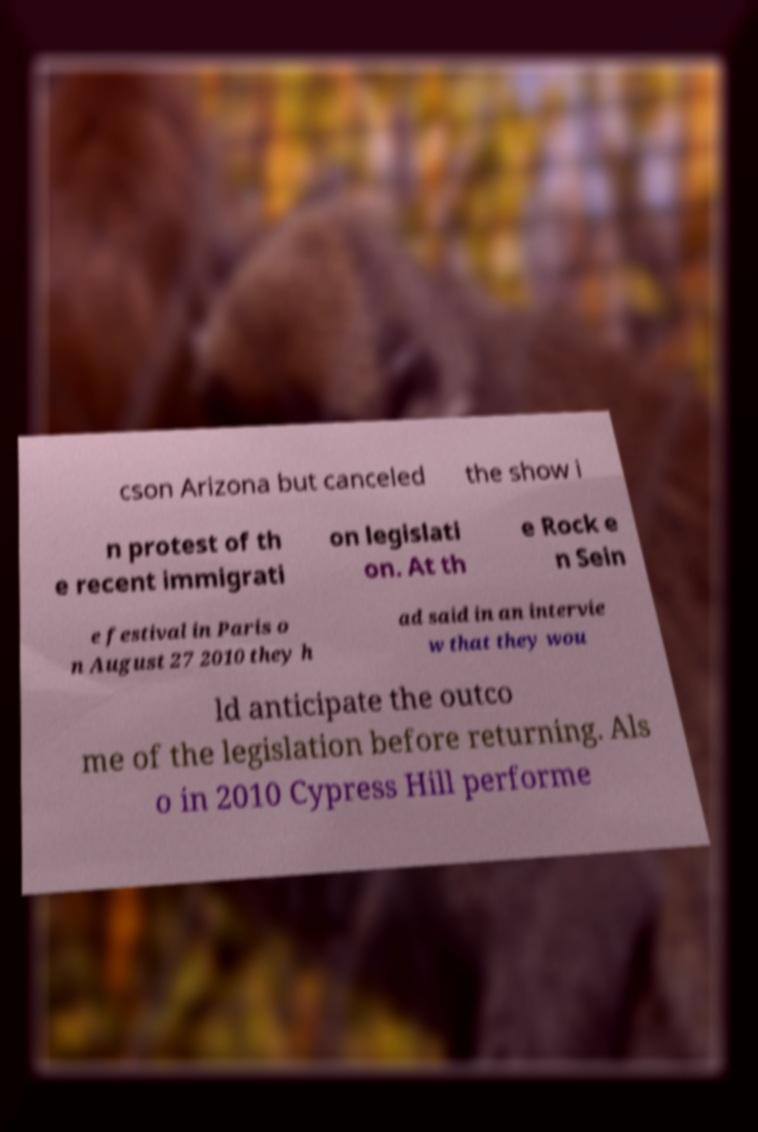Can you read and provide the text displayed in the image?This photo seems to have some interesting text. Can you extract and type it out for me? cson Arizona but canceled the show i n protest of th e recent immigrati on legislati on. At th e Rock e n Sein e festival in Paris o n August 27 2010 they h ad said in an intervie w that they wou ld anticipate the outco me of the legislation before returning. Als o in 2010 Cypress Hill performe 